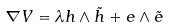<formula> <loc_0><loc_0><loc_500><loc_500>\nabla V = \lambda h \wedge \tilde { h } + e \wedge \tilde { e }</formula> 